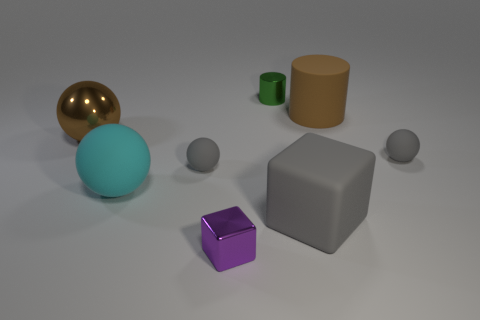Subtract 1 balls. How many balls are left? 3 Add 2 big cylinders. How many objects exist? 10 Subtract all cylinders. How many objects are left? 6 Subtract all brown cylinders. Subtract all small purple cubes. How many objects are left? 6 Add 5 gray things. How many gray things are left? 8 Add 3 gray matte cubes. How many gray matte cubes exist? 4 Subtract 0 yellow cubes. How many objects are left? 8 